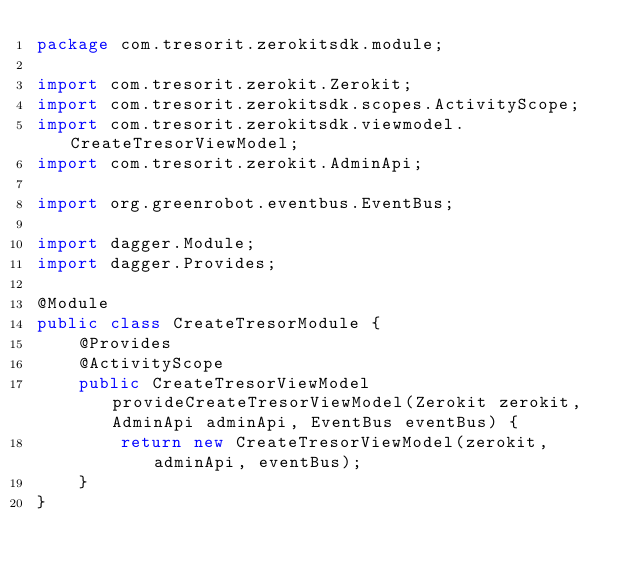<code> <loc_0><loc_0><loc_500><loc_500><_Java_>package com.tresorit.zerokitsdk.module;

import com.tresorit.zerokit.Zerokit;
import com.tresorit.zerokitsdk.scopes.ActivityScope;
import com.tresorit.zerokitsdk.viewmodel.CreateTresorViewModel;
import com.tresorit.zerokit.AdminApi;

import org.greenrobot.eventbus.EventBus;

import dagger.Module;
import dagger.Provides;

@Module
public class CreateTresorModule {
    @Provides
    @ActivityScope
    public CreateTresorViewModel provideCreateTresorViewModel(Zerokit zerokit, AdminApi adminApi, EventBus eventBus) {
        return new CreateTresorViewModel(zerokit, adminApi, eventBus);
    }
}
</code> 